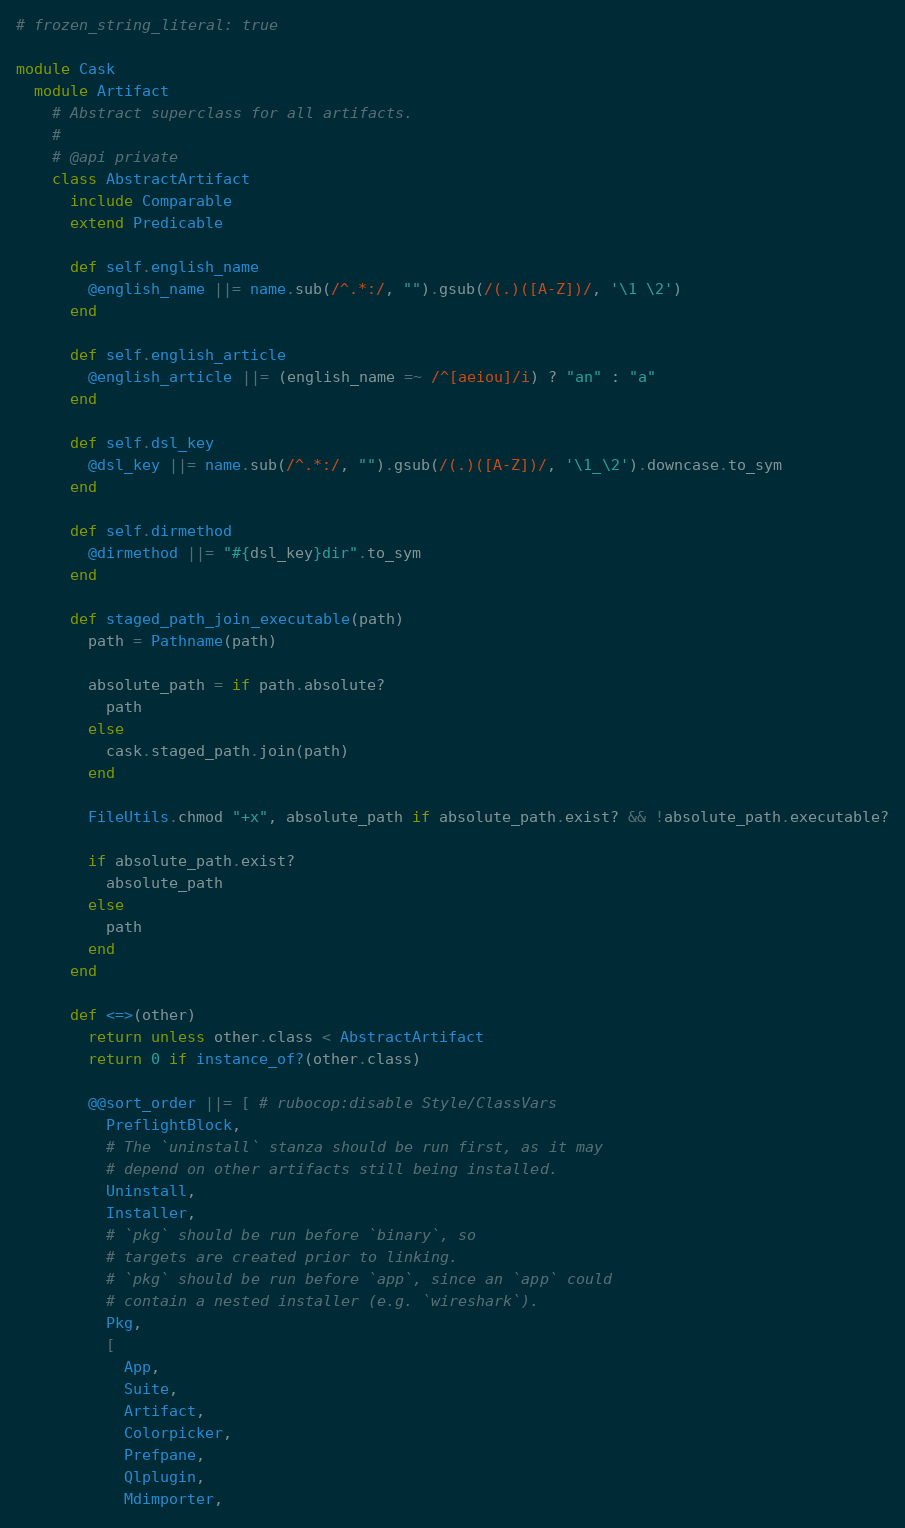<code> <loc_0><loc_0><loc_500><loc_500><_Ruby_># frozen_string_literal: true

module Cask
  module Artifact
    # Abstract superclass for all artifacts.
    #
    # @api private
    class AbstractArtifact
      include Comparable
      extend Predicable

      def self.english_name
        @english_name ||= name.sub(/^.*:/, "").gsub(/(.)([A-Z])/, '\1 \2')
      end

      def self.english_article
        @english_article ||= (english_name =~ /^[aeiou]/i) ? "an" : "a"
      end

      def self.dsl_key
        @dsl_key ||= name.sub(/^.*:/, "").gsub(/(.)([A-Z])/, '\1_\2').downcase.to_sym
      end

      def self.dirmethod
        @dirmethod ||= "#{dsl_key}dir".to_sym
      end

      def staged_path_join_executable(path)
        path = Pathname(path)

        absolute_path = if path.absolute?
          path
        else
          cask.staged_path.join(path)
        end

        FileUtils.chmod "+x", absolute_path if absolute_path.exist? && !absolute_path.executable?

        if absolute_path.exist?
          absolute_path
        else
          path
        end
      end

      def <=>(other)
        return unless other.class < AbstractArtifact
        return 0 if instance_of?(other.class)

        @@sort_order ||= [ # rubocop:disable Style/ClassVars
          PreflightBlock,
          # The `uninstall` stanza should be run first, as it may
          # depend on other artifacts still being installed.
          Uninstall,
          Installer,
          # `pkg` should be run before `binary`, so
          # targets are created prior to linking.
          # `pkg` should be run before `app`, since an `app` could
          # contain a nested installer (e.g. `wireshark`).
          Pkg,
          [
            App,
            Suite,
            Artifact,
            Colorpicker,
            Prefpane,
            Qlplugin,
            Mdimporter,</code> 